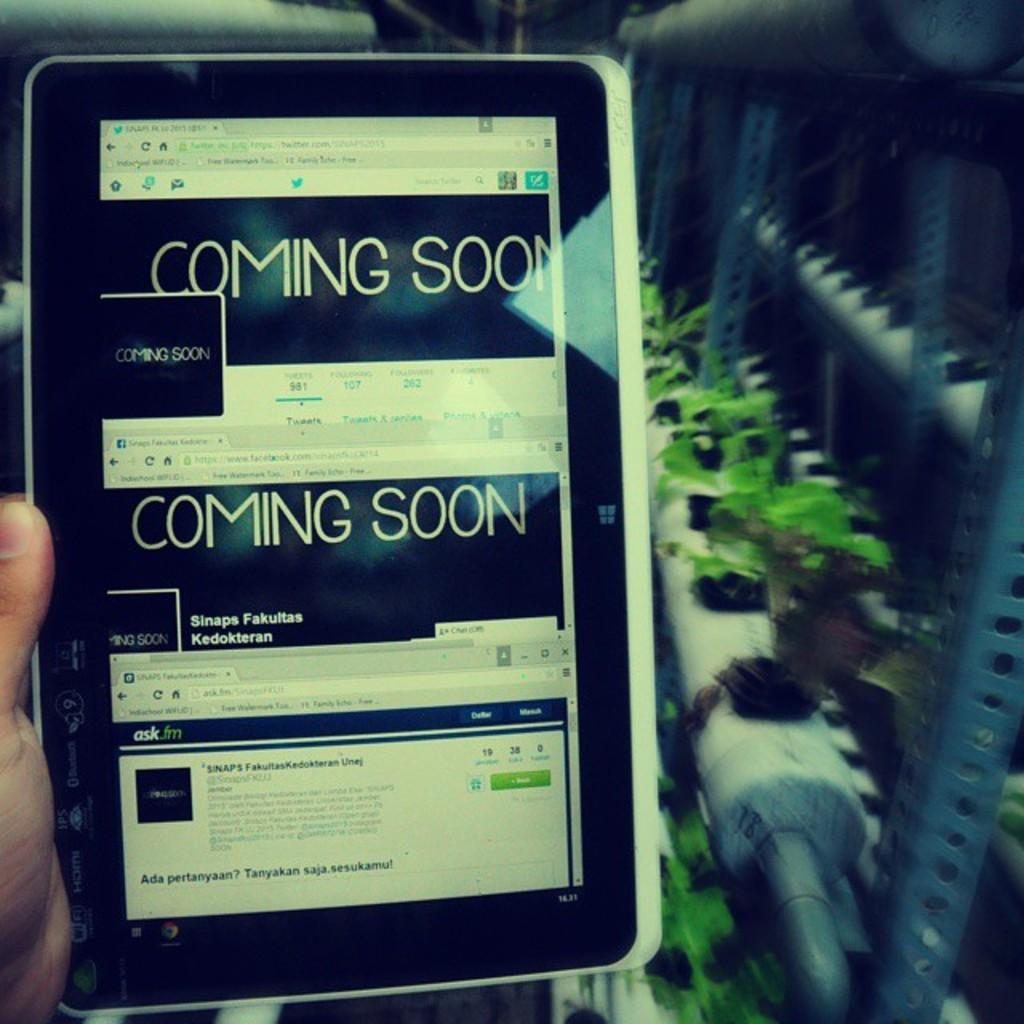What electronic device is visible in the image? There is a tablet in the image. Who is holding the tablet? The tablet is being held by a person. What can be seen on the tablet's screen? There are texts and images on the tablet. What type of objects are on racks in the image? There are plants on racks in the image. How would you describe the background of the image? The background of the image is blurred. What type of bead is being used to gain knowledge in the image? There is no bead or knowledge-gaining activity depicted in the image; it features a person holding a tablet with texts and images on the screen. 